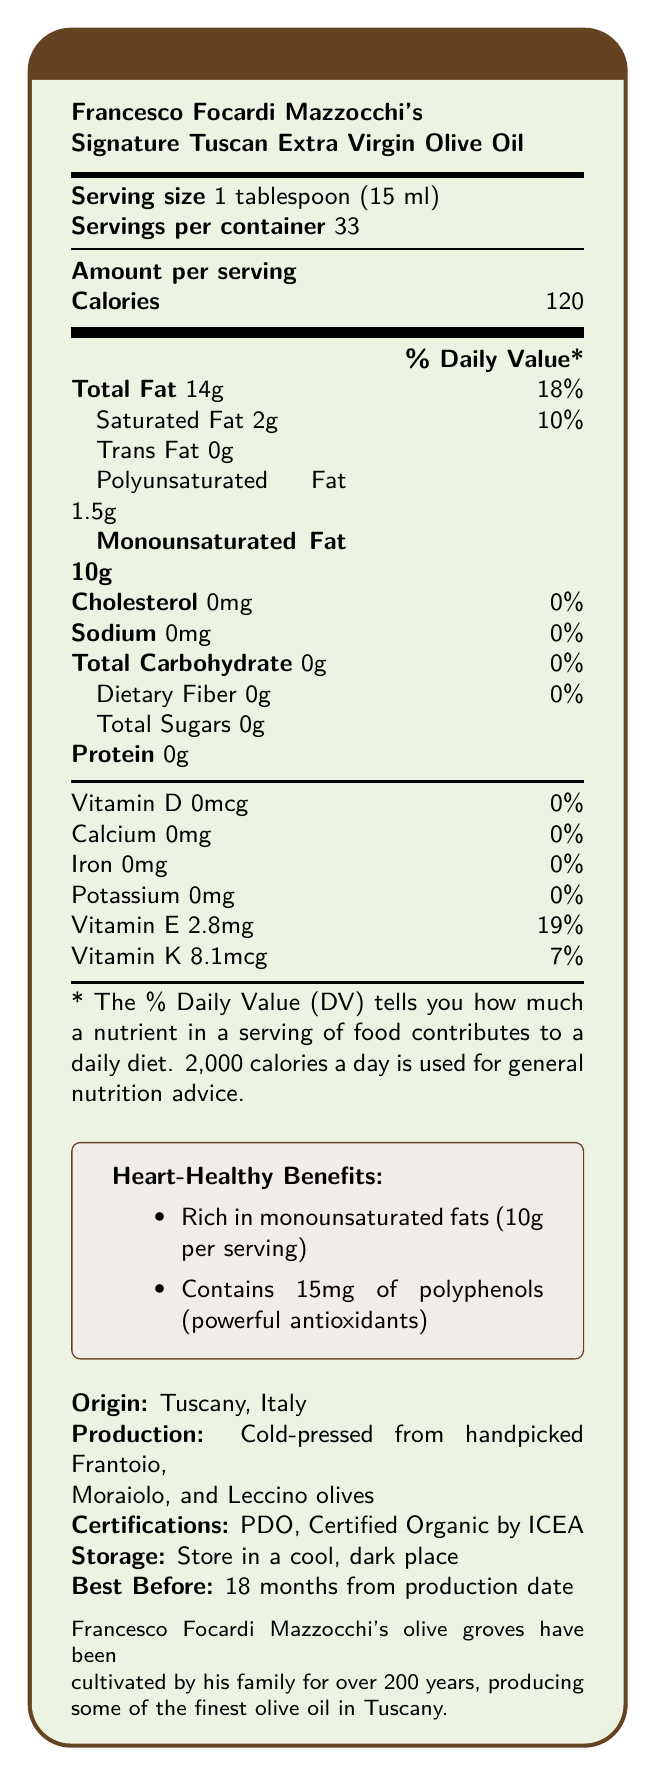what is the product name? The product name is clearly stated at the top of the document.
Answer: Francesco Focardi Mazzocchi's Signature Tuscan Extra Virgin Olive Oil what is the serving size? The serving size is indicated under the product name at the beginning of the document.
Answer: 1 tablespoon (15 ml) how many servings are there per container? The number of servings per container is listed right after the serving size.
Answer: 33 what is the amount of monounsaturated fat per serving? The document lists monounsaturated fat as 10g per serving under the amount per serving section.
Answer: 10g what percentage of daily value does total fat provide per serving? The percentage of daily value for total fat is given next to the total fat amount.
Answer: 18% which type of fat is richer in Francesco Focardi Mazzocchi's olive oil? A. Saturated Fat B. Trans Fat C. Polyunsaturated Fat D. Monounsaturated Fat The document highlights that the olive oil is rich in heart-healthy monounsaturated fats at 10g per serving.
Answer: D. Monounsaturated Fat what is the amount of vitamin E per serving, and what percentage of the daily value does it provide? The amount of vitamin E per serving is 2.8mg, and this provides 19% of the daily value.
Answer: 2.8mg, 19% where is Francesco Focardi Mazzocchi's olive oil produced? A. Spain B. Greece C. Italy D. France The origin of the olive oil is listed as Tuscany, Italy.
Answer: C. Italy is there any cholesterol in the olive oil? The document states that there is 0mg of cholesterol per serving.
Answer: No what is the main idea of this document? The document presents comprehensive nutritional information while emphasizing the health benefits of the olive oil due to its monounsaturated fats and polyphenols, production methods, certifications, and storage guidelines.
Answer: The document provides detailed nutrition facts for Francesco Focardi Mazzocchi's Signature Tuscan Extra Virgin Olive Oil, highlighting its heart-healthy monounsaturated fats and rich antioxidant content, and includes additional product information and storage instructions. how does Francesco Focardi Mazzocchi's olive oil contribute to heart health? The document explicitly mentions that the olive oil is "Rich in heart-healthy monounsaturated fats" with 10g per serving.
Answer: It is rich in monounsaturated fats which are beneficial for heart health. how many polyphenols are present per serving, and what is their benefit? The document lists 15mg of polyphenols per serving and describes them as powerful antioxidants.
Answer: 15mg; they are powerful antioxidants what is the best-before duration for the olive oil? The best-before information states 18 months from the production date.
Answer: 18 months from production date what family history is associated with Francesco Focardi Mazzocchi's olive oil production? The document mentions that the olive groves have been cultivated by Francesco Focardi Mazzocchi’s family for over 200 years, emphasizing the long-standing tradition and quality.
Answer: Francesco Focardi Mazzocchi's family has cultivated olive groves for over 200 years, producing fine olive oil in Tuscany. does the olive oil contain any added sugars? The document lists 0g of total sugars.
Answer: No what is the production method for the olive oil? The production method is described as cold-pressed from handpicked Frantoio, Moraiolo, and Leccino olives.
Answer: Cold-pressed from handpicked Frantoio, Moraiolo, and Leccino olives what certifications does the olive oil have? The document lists two certifications: PDO and Certified Organic by ICEA.
Answer: Protected Designation of Origin (PDO), Certified Organic by ICEA what does the serving size 1? The given serving size information is complete; the interpretation of "1" in the context is unclear.
Answer: Cannot be determined what country is Francesco Focardi Mazzocchi's family from? The document mentions Tuscany, Italy, but it does not explicitly verify the nationality or specific origin of Francesco Focardi Mazzocchi's family.
Answer: Not enough information 